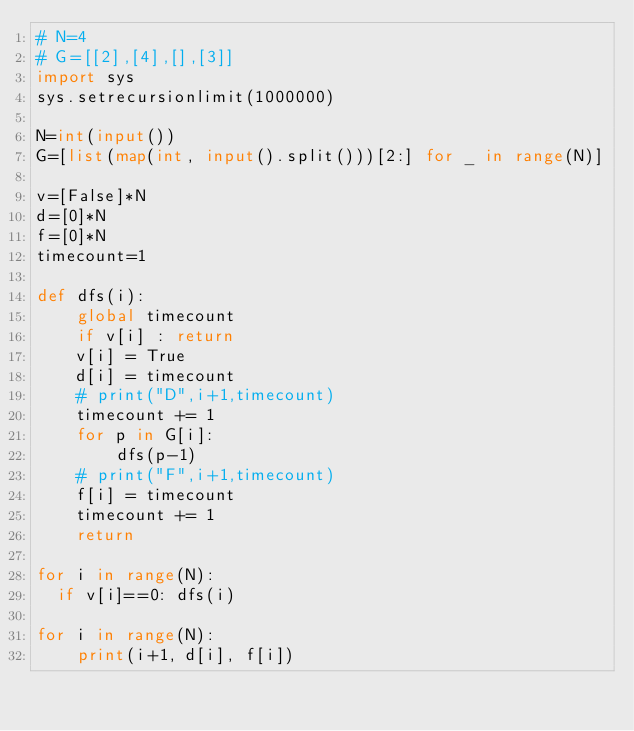<code> <loc_0><loc_0><loc_500><loc_500><_Python_># N=4
# G=[[2],[4],[],[3]]
import sys
sys.setrecursionlimit(1000000)

N=int(input())
G=[list(map(int, input().split()))[2:] for _ in range(N)]

v=[False]*N
d=[0]*N
f=[0]*N
timecount=1

def dfs(i):
    global timecount
    if v[i] : return
    v[i] = True
    d[i] = timecount
    # print("D",i+1,timecount)
    timecount += 1
    for p in G[i]:
        dfs(p-1)
    # print("F",i+1,timecount)
    f[i] = timecount
    timecount += 1
    return

for i in range(N):
  if v[i]==0: dfs(i)

for i in range(N):
    print(i+1, d[i], f[i])
</code> 